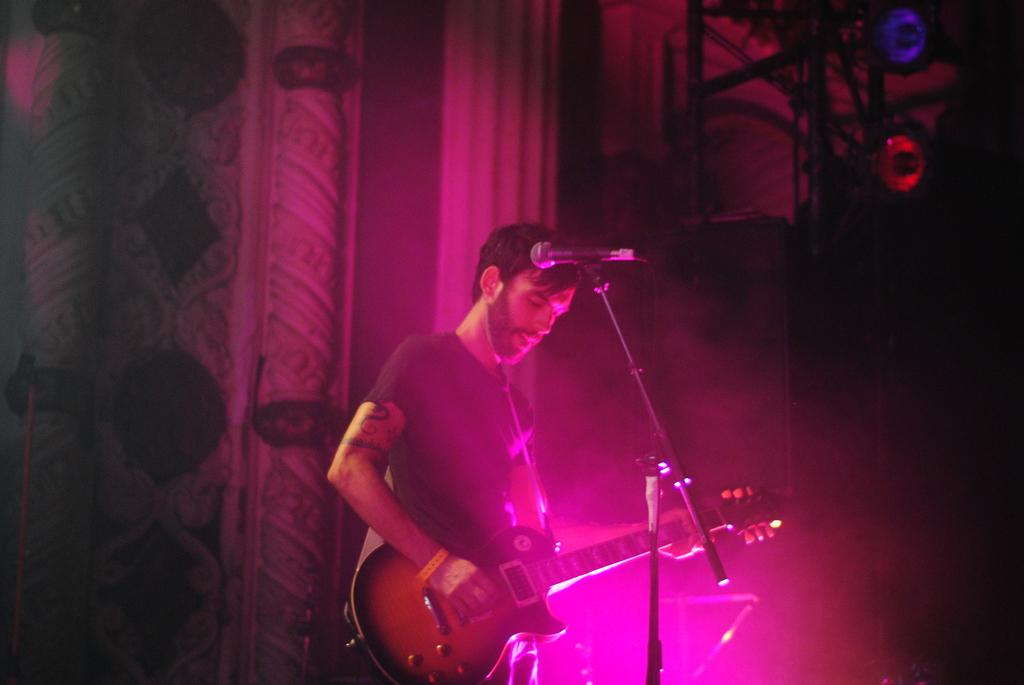What is the person in the image doing? The person is standing on a stage and playing a musical instrument. Can you see any goldfish swimming in the background of the image? There are no goldfish present in the image. 